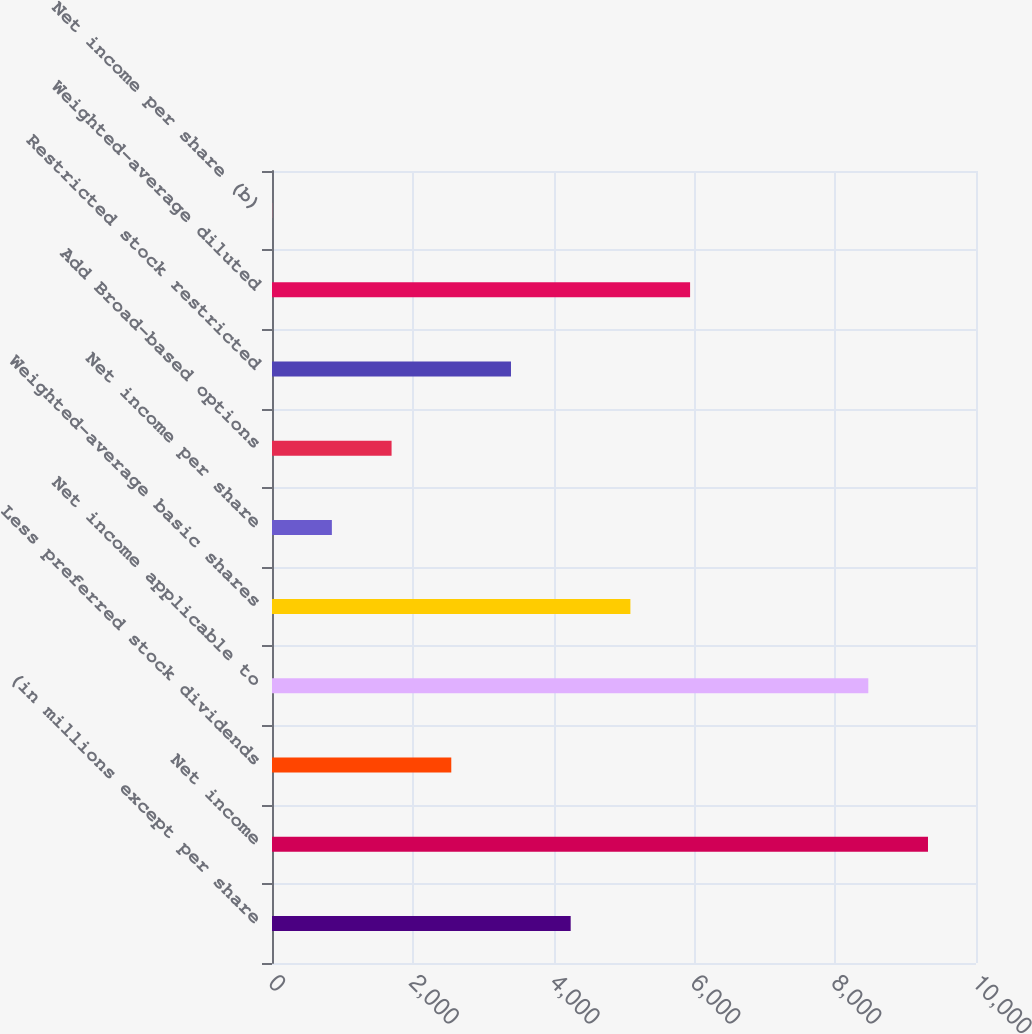<chart> <loc_0><loc_0><loc_500><loc_500><bar_chart><fcel>(in millions except per share<fcel>Net income<fcel>Less preferred stock dividends<fcel>Net income applicable to<fcel>Weighted-average basic shares<fcel>Net income per share<fcel>Add Broad-based options<fcel>Restricted stock restricted<fcel>Weighted-average diluted<fcel>Net income per share (b)<nl><fcel>4242.68<fcel>9318.06<fcel>2546.56<fcel>8470<fcel>5090.74<fcel>850.44<fcel>1698.5<fcel>3394.62<fcel>5938.8<fcel>2.38<nl></chart> 